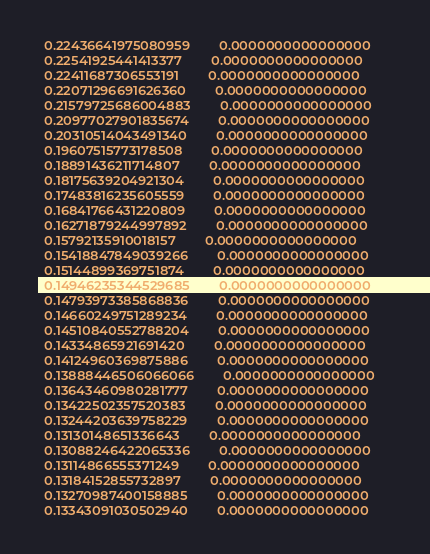<code> <loc_0><loc_0><loc_500><loc_500><_SML_>  0.22436641975080959        0.0000000000000000     
  0.22541925441413377        0.0000000000000000     
  0.22411687306553191        0.0000000000000000     
  0.22071296691626360        0.0000000000000000     
  0.21579725686004883        0.0000000000000000     
  0.20977027901835674        0.0000000000000000     
  0.20310514043491340        0.0000000000000000     
  0.19607515773178508        0.0000000000000000     
  0.18891436211714807        0.0000000000000000     
  0.18175639204921304        0.0000000000000000     
  0.17483816235605559        0.0000000000000000     
  0.16841766431220809        0.0000000000000000     
  0.16271879244997892        0.0000000000000000     
  0.15792135910018157        0.0000000000000000     
  0.15418847849039266        0.0000000000000000     
  0.15144899369751874        0.0000000000000000     
  0.14946235344529685        0.0000000000000000     
  0.14793973385868836        0.0000000000000000     
  0.14660249751289234        0.0000000000000000     
  0.14510840552788204        0.0000000000000000     
  0.14334865921691420        0.0000000000000000     
  0.14124960369875886        0.0000000000000000     
  0.13888446506066066        0.0000000000000000     
  0.13643460980281777        0.0000000000000000     
  0.13422502357520383        0.0000000000000000     
  0.13244203639758229        0.0000000000000000     
  0.13130148651336643        0.0000000000000000     
  0.13088246422065336        0.0000000000000000     
  0.13114866555371249        0.0000000000000000     
  0.13184152855732897        0.0000000000000000     
  0.13270987400158885        0.0000000000000000     
  0.13343091030502940        0.0000000000000000     </code> 